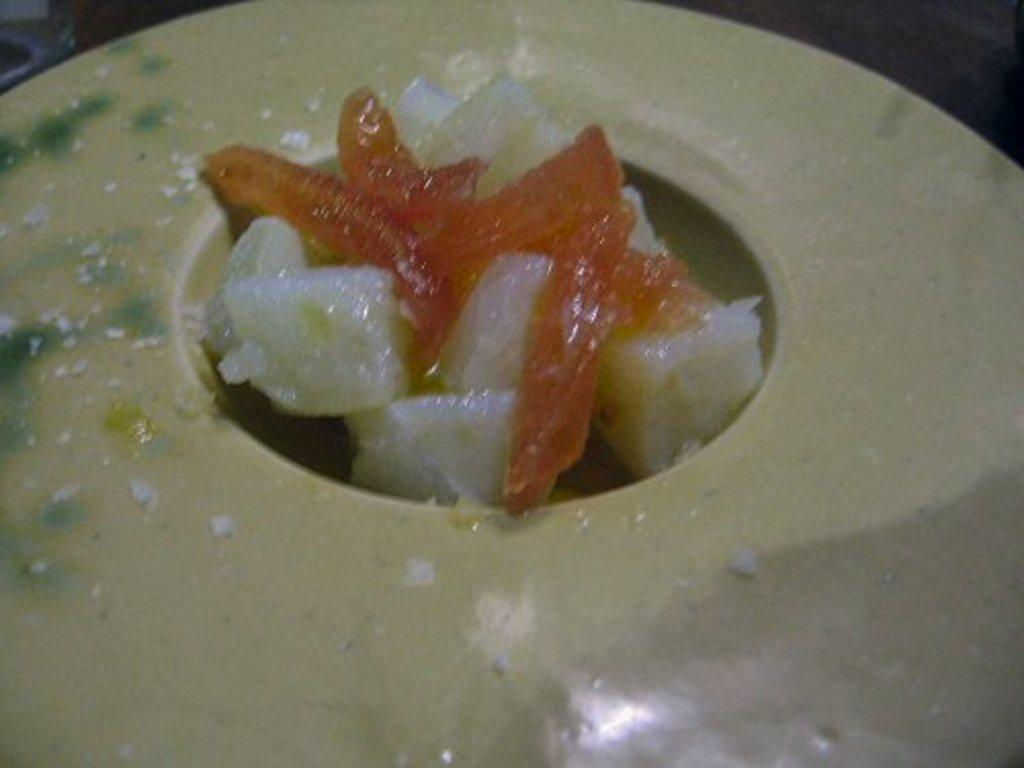What is present in the image? There is a bowl in the image. What is inside the bowl? There is a food item in the bowl. How does the earthquake affect the bowl in the image? There is no earthquake present in the image, so its effect cannot be determined. 